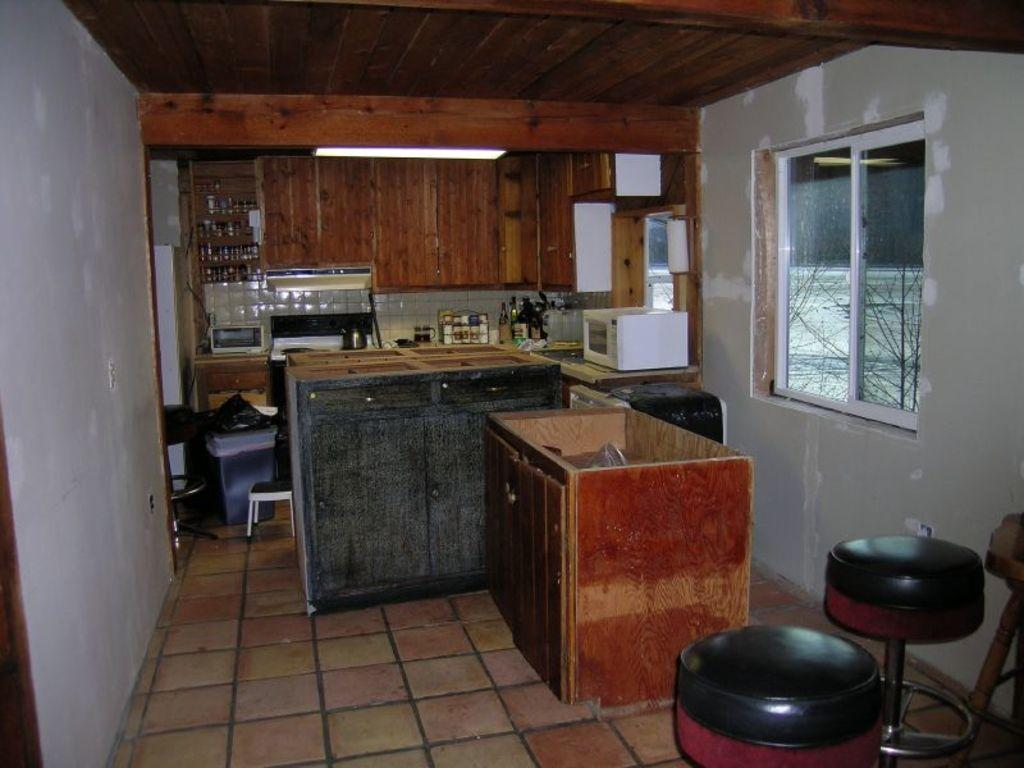How many stools are in the image? There are two stools in the image. What is located in the right corner of the image? There is a glass window in the right corner of the image. How many tables are in the image? There are two tables in the image. What appliance can be seen in the image? There is a microwave in the image. What else can be seen in the background of the image? There are other objects visible in the background of the image. Can you see anyone writing a good-bye note in the image? There is no writing or good-bye note present in the image. Is there a hand visible in the image? There is no hand visible in the image. 